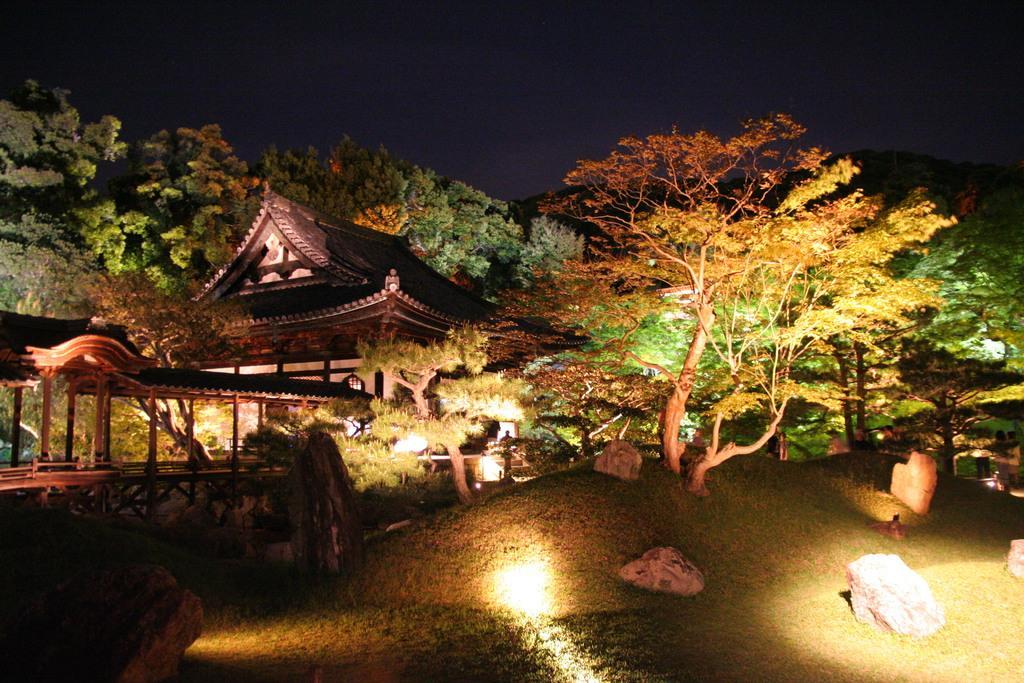Please provide a concise description of this image. In this image in the front there's grass on the ground and there are stones. In the background there are trees and there is a house and there is a tent. 